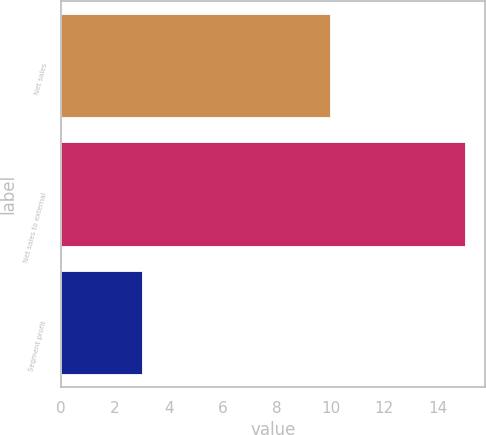Convert chart to OTSL. <chart><loc_0><loc_0><loc_500><loc_500><bar_chart><fcel>Net sales<fcel>Net sales to external<fcel>Segment profit<nl><fcel>10<fcel>15<fcel>3<nl></chart> 